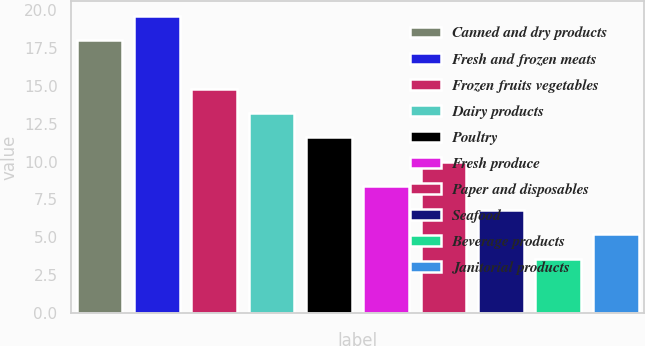Convert chart. <chart><loc_0><loc_0><loc_500><loc_500><bar_chart><fcel>Canned and dry products<fcel>Fresh and frozen meats<fcel>Frozen fruits vegetables<fcel>Dairy products<fcel>Poultry<fcel>Fresh produce<fcel>Paper and disposables<fcel>Seafood<fcel>Beverage products<fcel>Janitorial products<nl><fcel>18<fcel>19.6<fcel>14.8<fcel>13.2<fcel>11.6<fcel>8.4<fcel>10<fcel>6.8<fcel>3.6<fcel>5.2<nl></chart> 